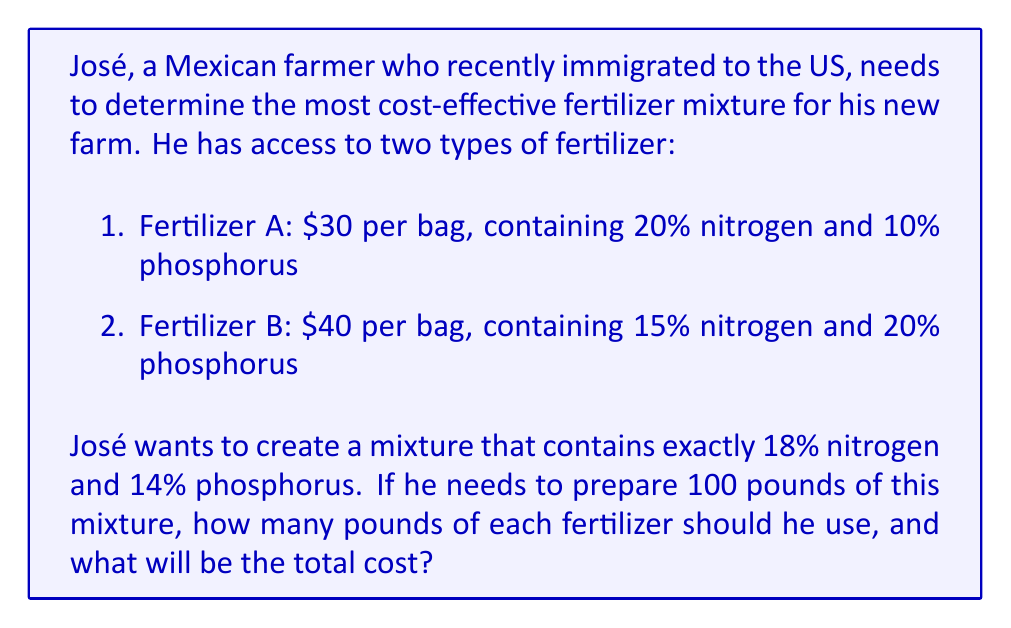Help me with this question. Let's approach this step-by-step:

1) Let $x$ be the number of pounds of Fertilizer A and $y$ be the number of pounds of Fertilizer B.

2) The total mixture should be 100 pounds, so:

   $$x + y = 100$$

3) For nitrogen, we can set up the equation:

   $$0.20x + 0.15y = 0.18(100)$$

   This is because 20% of $x$ plus 15% of $y$ should equal 18% of the total mixture.

4) For phosphorus, we can set up a similar equation:

   $$0.10x + 0.20y = 0.14(100)$$

5) Simplifying these equations:

   $$x + y = 100$$
   $$20x + 15y = 1800$$
   $$10x + 20y = 1400$$

6) From the first equation, we can express $y$ in terms of $x$:

   $$y = 100 - x$$

7) Substituting this into the second equation:

   $$20x + 15(100 - x) = 1800$$
   $$20x + 1500 - 15x = 1800$$
   $$5x = 300$$
   $$x = 60$$

8) Therefore, $y = 100 - 60 = 40$

9) To calculate the cost:
   - 60 pounds of Fertilizer A at $\$30$ per bag: $60 * (\$30/100) = \$18$
   - 40 pounds of Fertilizer B at $\$40$ per bag: $40 * (\$40/100) = \$16$

   Total cost: $\$18 + \$16 = \$34$
Answer: José should use 60 pounds of Fertilizer A and 40 pounds of Fertilizer B. The total cost will be $\$34$. 